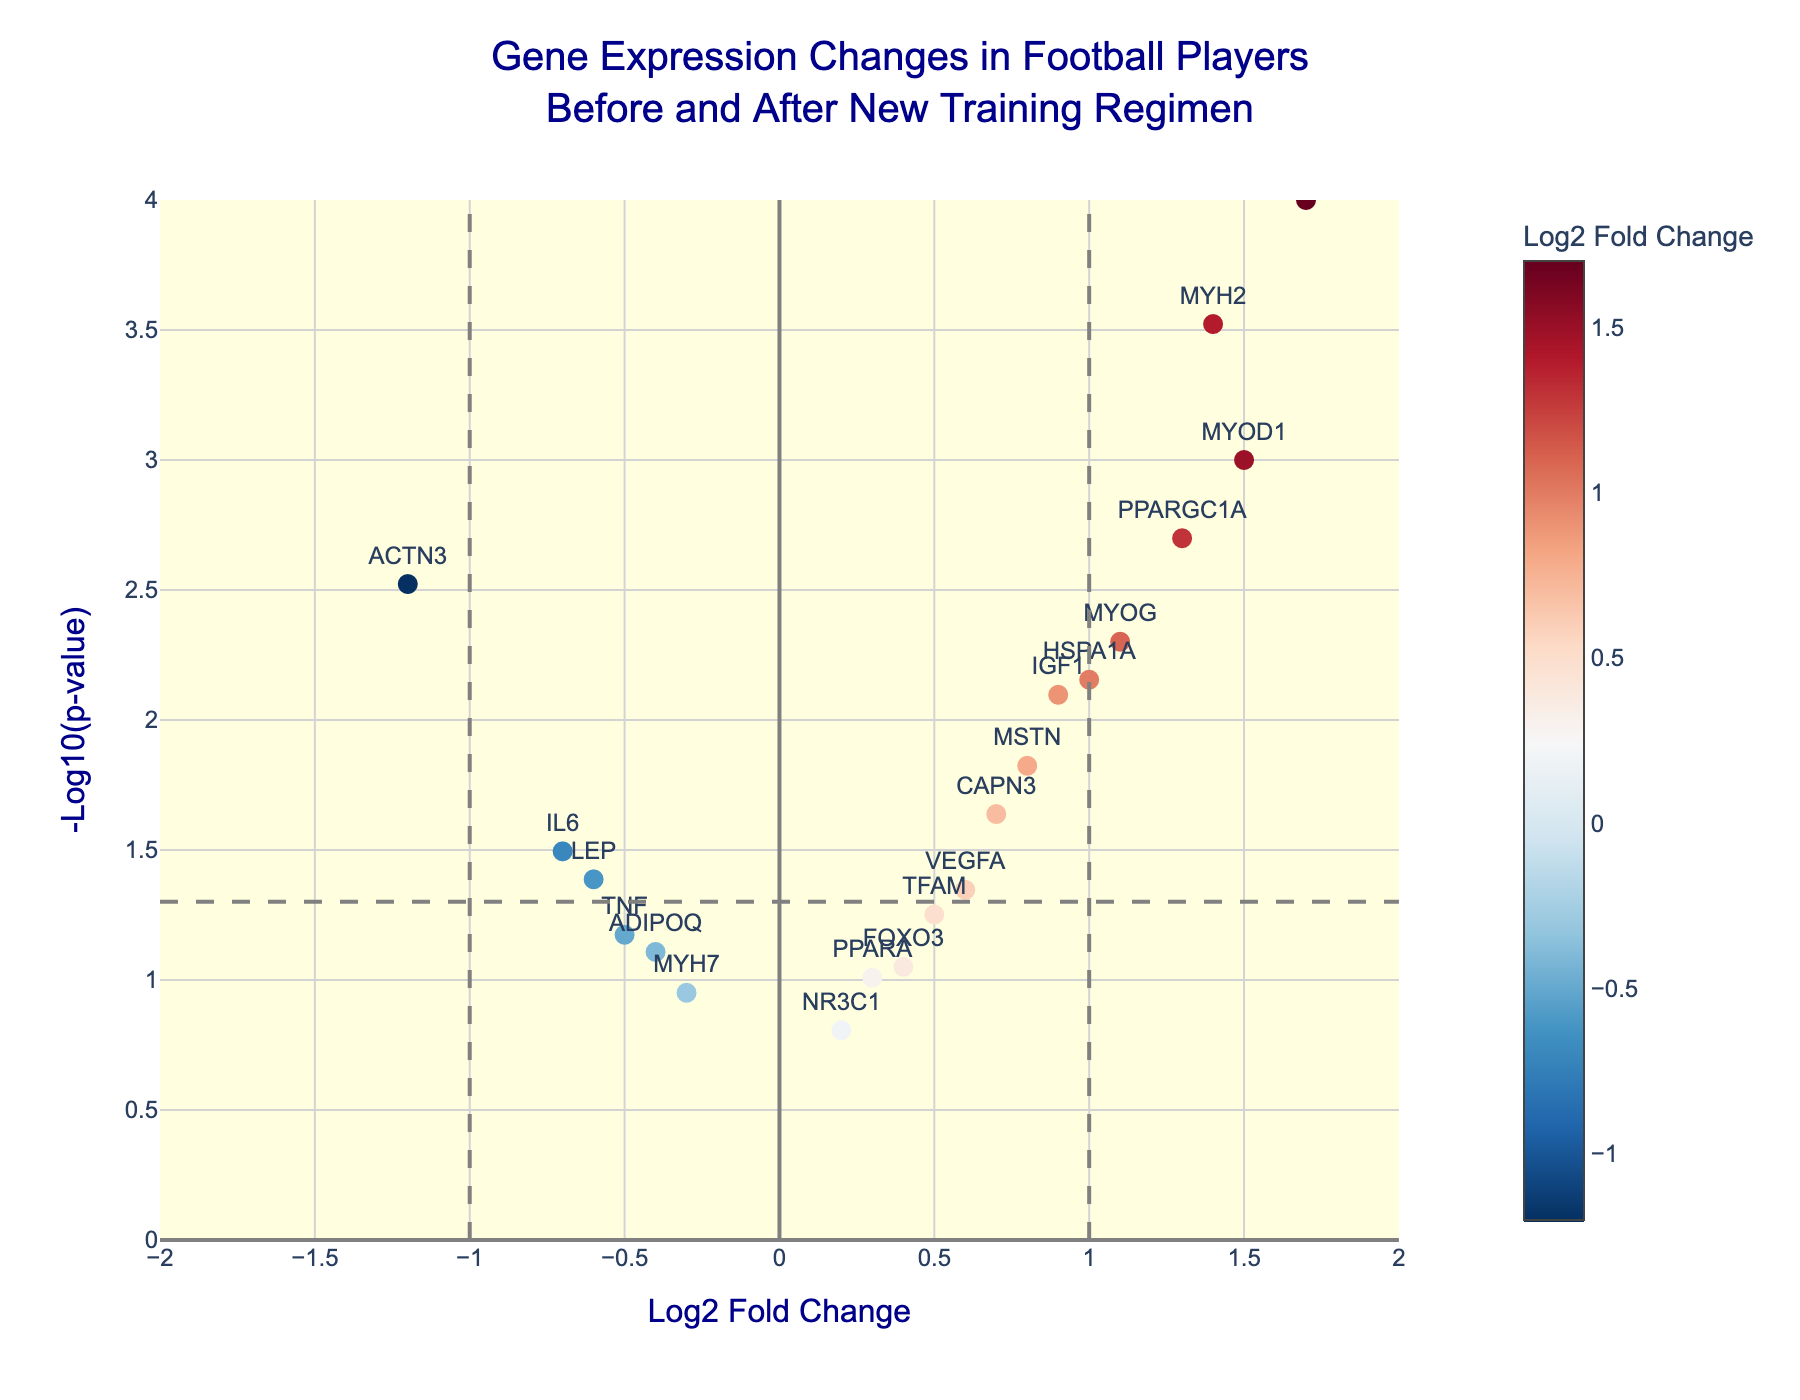What is the title of the volcano plot? The title is displayed at the top of the plot in large, dark blue font. It reads: "Gene Expression Changes in Football Players Before and After New Training Regimen".
Answer: Gene Expression Changes in Football Players Before and After New Training Regimen What does the x-axis represent? The x-axis is labeled "Log2 Fold Change", indicating that it represents the log2 of the fold change in gene expression.
Answer: Log2 Fold Change How many genes have a p-value less than 0.05? The -log10(p-value) threshold line for p=0.05 is marked on the plot. Count the points that are above this horizontal line. There are 12 points above this line.
Answer: 12 Which gene has the highest log2 fold change? The gene with the highest log2 fold change will be the point farthest to the right on the x-axis. It is marked as MYH1 with a log2 fold change of 1.7.
Answer: MYH1 Which gene has the smallest p-value? The smallest p-value corresponds to the highest -log10(p-value). The point with the highest y-axis value is MYH1 with a -log10(p-value) equivalent to log10(0.0001).
Answer: MYH1 What is the color of the gene with the most negative log2 fold change? The gene with the most negative log2 fold change is ACTN3 (-1.2). The color is determined by the log2 fold change, with negative values colored towards blue in the RdBu_r colorscale.
Answer: Blue Compare MYH1 and VEGFA in terms of log2 fold change and p-value. MYH1 has a log2 fold change of 1.7 and a p-value of 0.0001. VEGFA has a log2 fold change of 0.6 and a p-value of 0.045. Therefore, MYH1 has a higher log2 fold change and a smaller p-value than VEGFA.
Answer: MYH1 has higher log2 fold change and smaller p-value How many genes have a log2 fold change greater than 1 and are significant (p < 0.05)? Significant genes (p < 0.05) are above the horizontal threshold line. Among these, count the points that have log2 fold changes greater than 1. The genes are MYOD1, PPARGC1A, MYH1, and MYH2, totaling 4 genes.
Answer: 4 Which gene with a log2 fold change less than 0 is closest to being non-significant (p >= 0.05)? Among the genes with a log2 fold change less than 0, the one with the highest p-value, but still less than 0.05, is LEP with a p-value of 0.041.
Answer: LEP Based on their positions, which gene between MYOG and HSPA1A shows greater statistical significance? Higher statistical significance corresponds to a smaller p-value, indicating a higher position on the plot. Compare the y-values (-log10(p-values)) of MYOG and HSPA1A. MYOG is at 2.301 and HSPA1A is at 2.155. Therefore, MYOG shows greater statistical significance.
Answer: MYOG 